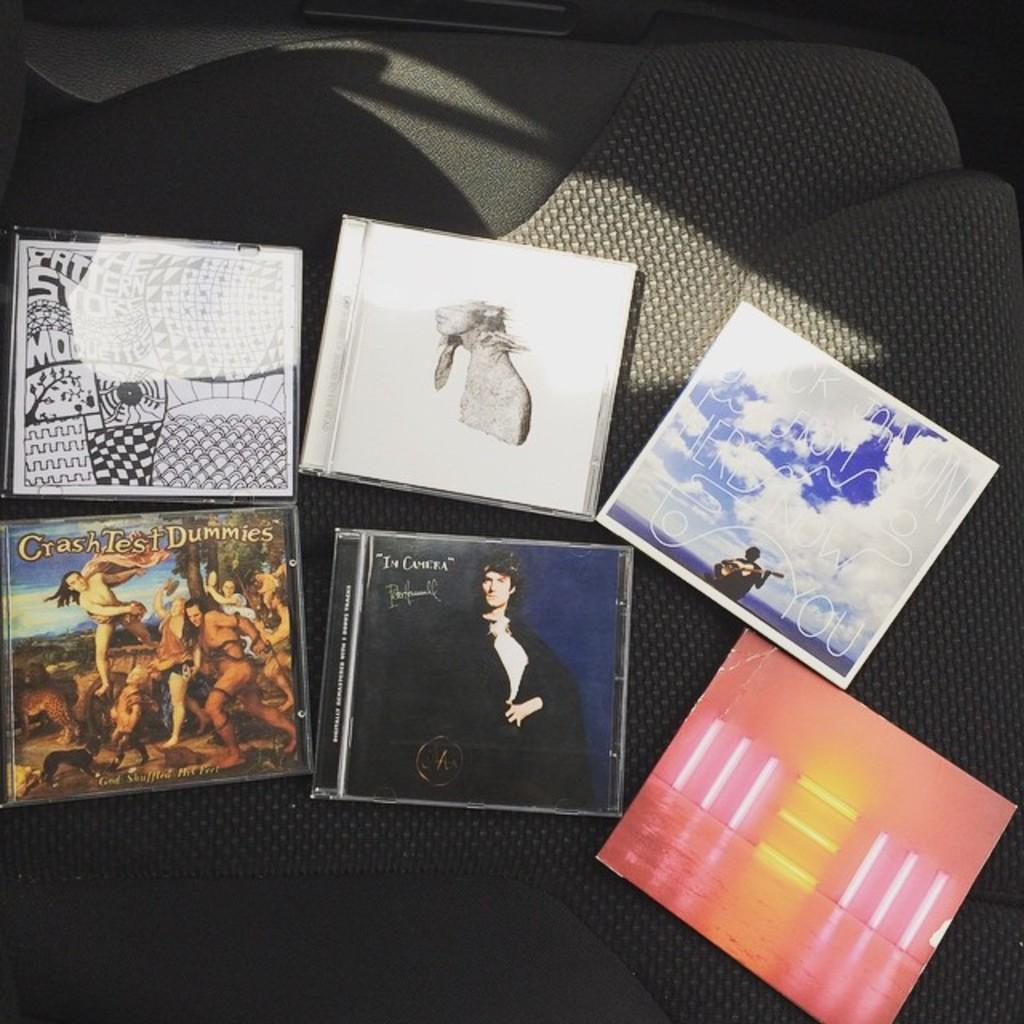What type of objects can be seen in the image? There are cassette covers in the image. Where are the cassette covers located? The cassette covers are placed on a seat. Is there a bomb hidden in the fog near the coast in the image? There is no mention of a bomb, fog, or coast in the image. The image only features cassette covers placed on a seat. 